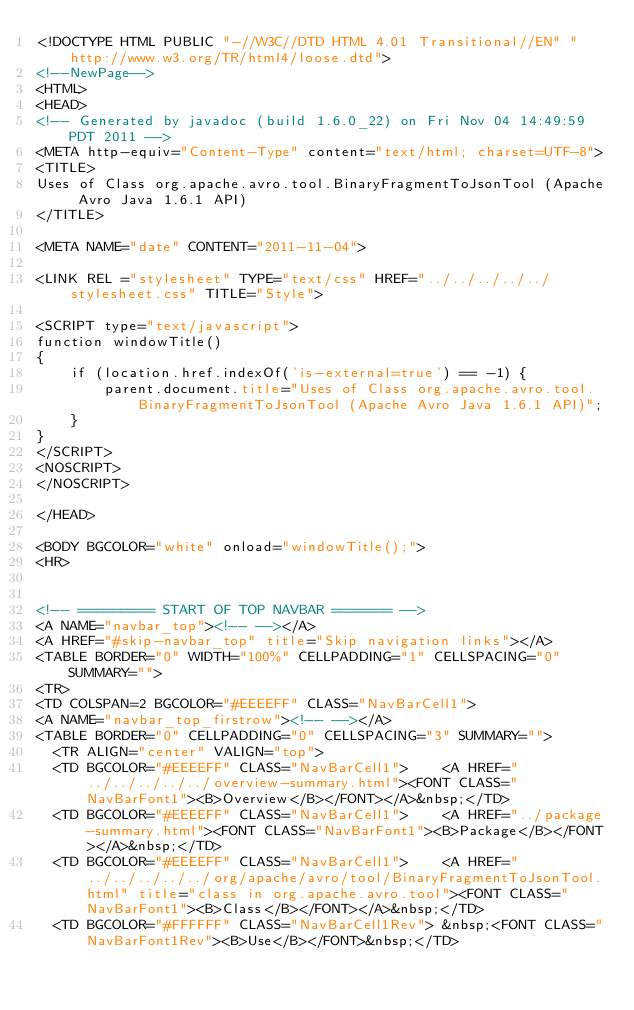<code> <loc_0><loc_0><loc_500><loc_500><_HTML_><!DOCTYPE HTML PUBLIC "-//W3C//DTD HTML 4.01 Transitional//EN" "http://www.w3.org/TR/html4/loose.dtd">
<!--NewPage-->
<HTML>
<HEAD>
<!-- Generated by javadoc (build 1.6.0_22) on Fri Nov 04 14:49:59 PDT 2011 -->
<META http-equiv="Content-Type" content="text/html; charset=UTF-8">
<TITLE>
Uses of Class org.apache.avro.tool.BinaryFragmentToJsonTool (Apache Avro Java 1.6.1 API)
</TITLE>

<META NAME="date" CONTENT="2011-11-04">

<LINK REL ="stylesheet" TYPE="text/css" HREF="../../../../../stylesheet.css" TITLE="Style">

<SCRIPT type="text/javascript">
function windowTitle()
{
    if (location.href.indexOf('is-external=true') == -1) {
        parent.document.title="Uses of Class org.apache.avro.tool.BinaryFragmentToJsonTool (Apache Avro Java 1.6.1 API)";
    }
}
</SCRIPT>
<NOSCRIPT>
</NOSCRIPT>

</HEAD>

<BODY BGCOLOR="white" onload="windowTitle();">
<HR>


<!-- ========= START OF TOP NAVBAR ======= -->
<A NAME="navbar_top"><!-- --></A>
<A HREF="#skip-navbar_top" title="Skip navigation links"></A>
<TABLE BORDER="0" WIDTH="100%" CELLPADDING="1" CELLSPACING="0" SUMMARY="">
<TR>
<TD COLSPAN=2 BGCOLOR="#EEEEFF" CLASS="NavBarCell1">
<A NAME="navbar_top_firstrow"><!-- --></A>
<TABLE BORDER="0" CELLPADDING="0" CELLSPACING="3" SUMMARY="">
  <TR ALIGN="center" VALIGN="top">
  <TD BGCOLOR="#EEEEFF" CLASS="NavBarCell1">    <A HREF="../../../../../overview-summary.html"><FONT CLASS="NavBarFont1"><B>Overview</B></FONT></A>&nbsp;</TD>
  <TD BGCOLOR="#EEEEFF" CLASS="NavBarCell1">    <A HREF="../package-summary.html"><FONT CLASS="NavBarFont1"><B>Package</B></FONT></A>&nbsp;</TD>
  <TD BGCOLOR="#EEEEFF" CLASS="NavBarCell1">    <A HREF="../../../../../org/apache/avro/tool/BinaryFragmentToJsonTool.html" title="class in org.apache.avro.tool"><FONT CLASS="NavBarFont1"><B>Class</B></FONT></A>&nbsp;</TD>
  <TD BGCOLOR="#FFFFFF" CLASS="NavBarCell1Rev"> &nbsp;<FONT CLASS="NavBarFont1Rev"><B>Use</B></FONT>&nbsp;</TD></code> 